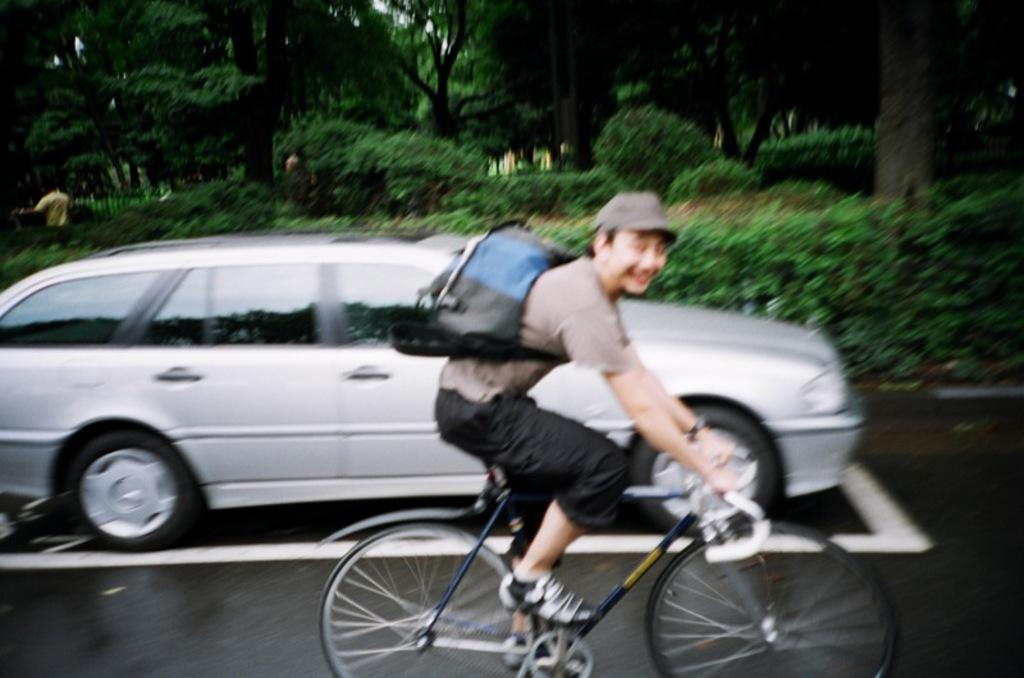What is the main subject of the image? The main subject of the image is a man. What is the man wearing on his back? The man is wearing a backpack bag. What is the man wearing on his head? The man is wearing a cap. What is the man doing in the image? The man is riding a bicycle. What is the color of the bicycle? The bicycle is silver in color. Can you describe the background of the image? In the background of the image, there is a person standing, trees, small plants, and bushes. What type of hearing aid is the man using in the image? There is no indication in the image that the man is using a hearing aid. What type of summer activities are being depicted in the image? The image does not depict any specific summer activities; it simply shows a man riding a bicycle. Is the man attending a camp in the image? There is no indication in the image that the man is attending a camp. 